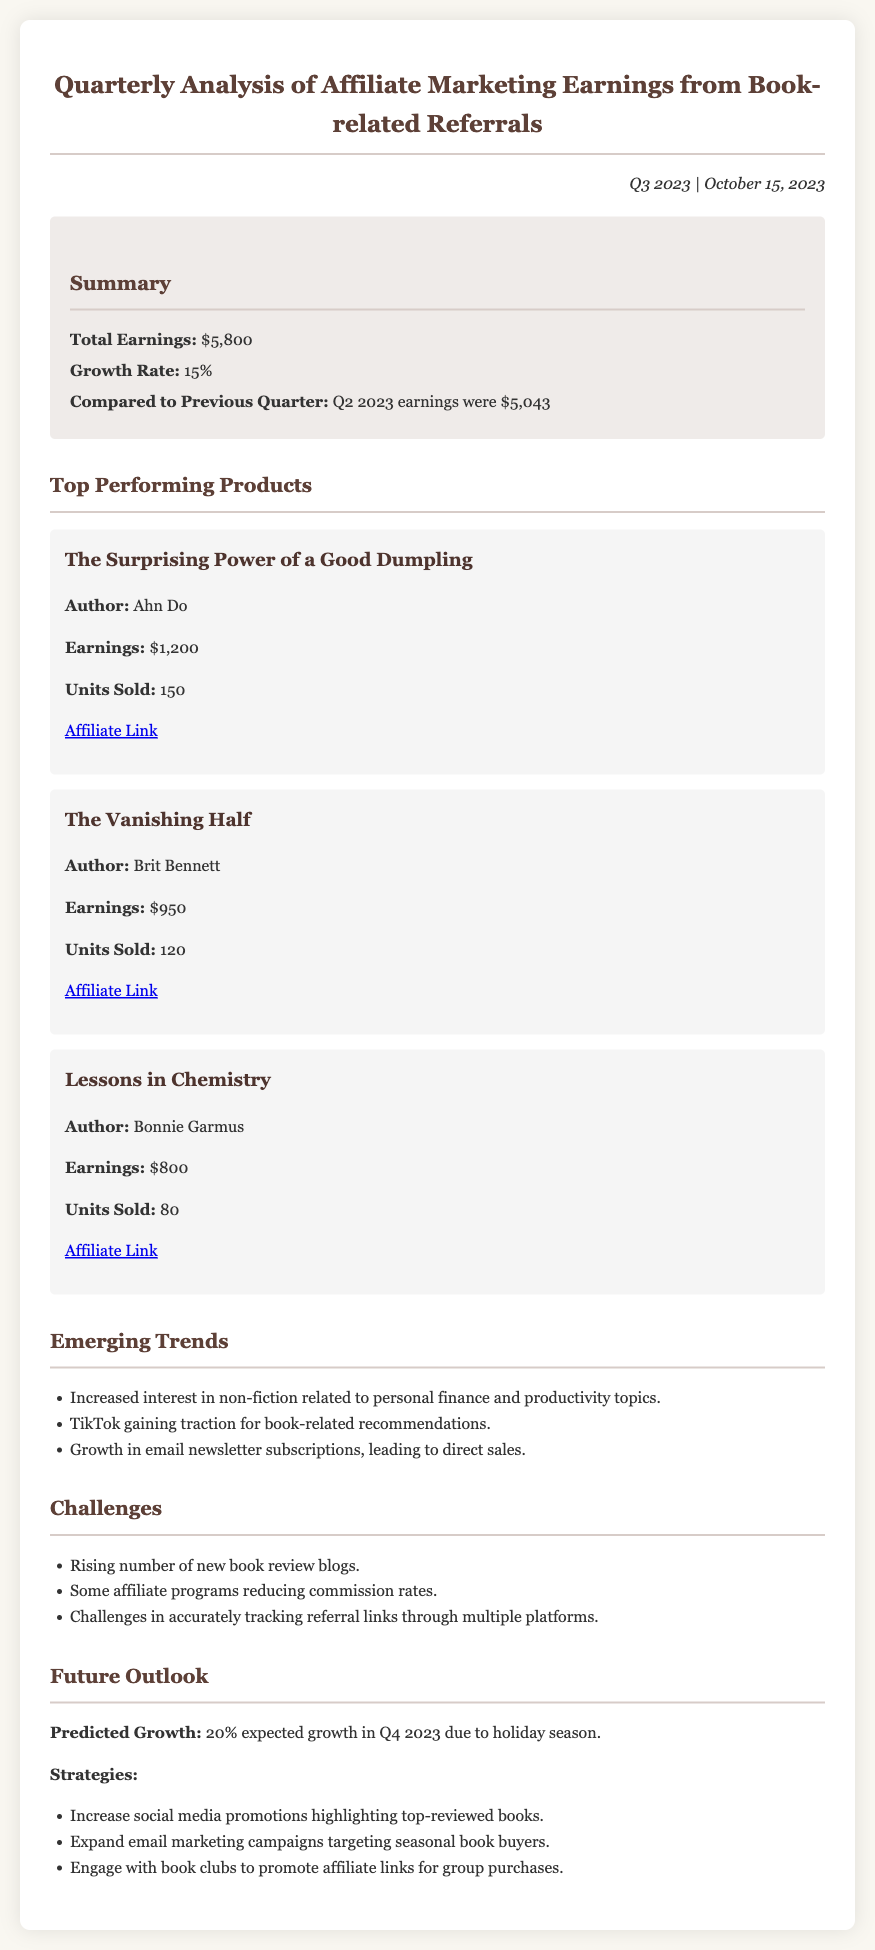What is the total earnings for Q3 2023? The total earnings is specified in the summary section of the document as $5,800.
Answer: $5,800 What was the growth rate compared to Q2 2023? The growth rate is highlighted in the summary section, indicating a rate of 15%.
Answer: 15% Who is the author of "The Vanishing Half"? The author of this book is listed in the top-performing products section as Brit Bennett.
Answer: Brit Bennett How many units of "Lessons in Chemistry" were sold? The number of units sold is explicitly stated for this product in the document as 80.
Answer: 80 What is the predicted growth for Q4 2023? The predicted growth is mentioned in the future outlook section as 20%.
Answer: 20% Which platform is gaining traction for book-related recommendations? The document identifies TikTok as the platform gaining traction.
Answer: TikTok What is a challenge mentioned in the report regarding affiliate programs? A challenge discussed in the report is the reduction of commission rates by some affiliate programs.
Answer: Reducing commission rates What recommendation is made for future strategies? One of the strategies mentioned is to increase social media promotions highlighting top-reviewed books.
Answer: Increase social media promotions What is the earnings from "The Surprising Power of a Good Dumpling"? The earnings for this product are specifically stated as $1,200 in the document.
Answer: $1,200 